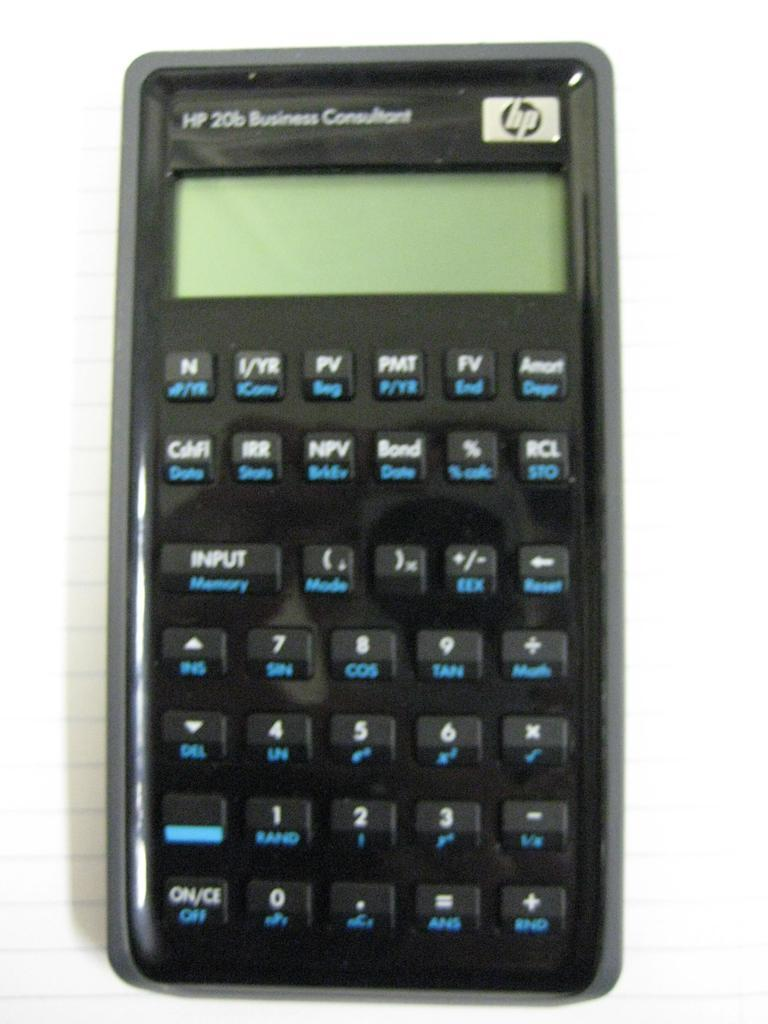<image>
Give a short and clear explanation of the subsequent image. A black hp brand calculator has many buttons. 